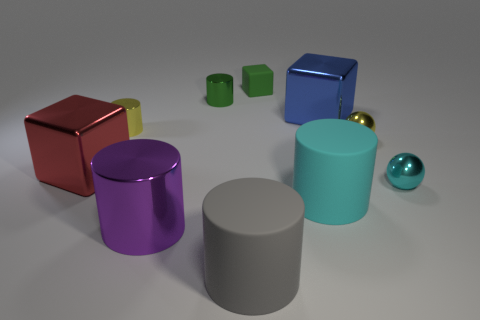How many brown balls are there?
Offer a terse response. 0. What number of things are blue rubber balls or yellow metal objects?
Ensure brevity in your answer.  2. How many balls are behind the rubber thing behind the large metallic object to the left of the yellow cylinder?
Your answer should be compact. 0. Is there any other thing that has the same color as the large shiny cylinder?
Ensure brevity in your answer.  No. There is a metal cylinder right of the purple metallic object; is it the same color as the small block to the right of the large red metallic cube?
Give a very brief answer. Yes. Is the number of blue metallic things behind the big gray cylinder greater than the number of big blue shiny objects in front of the red metal cube?
Provide a short and direct response. Yes. What is the cyan ball made of?
Keep it short and to the point. Metal. What is the shape of the tiny rubber object that is behind the big block on the left side of the large cylinder on the left side of the big gray object?
Make the answer very short. Cube. What number of other objects are there of the same material as the tiny yellow cylinder?
Offer a very short reply. 6. Do the big block in front of the large blue metal cube and the tiny yellow object that is right of the large shiny cylinder have the same material?
Your answer should be very brief. Yes. 